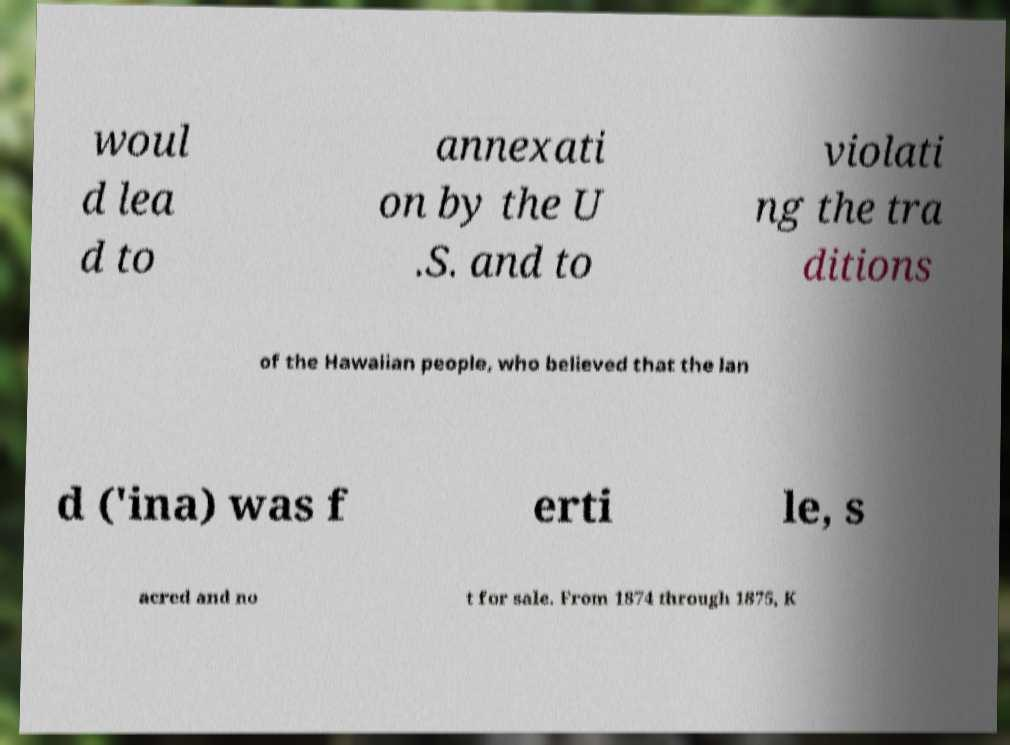Please read and relay the text visible in this image. What does it say? woul d lea d to annexati on by the U .S. and to violati ng the tra ditions of the Hawaiian people, who believed that the lan d ('ina) was f erti le, s acred and no t for sale. From 1874 through 1875, K 